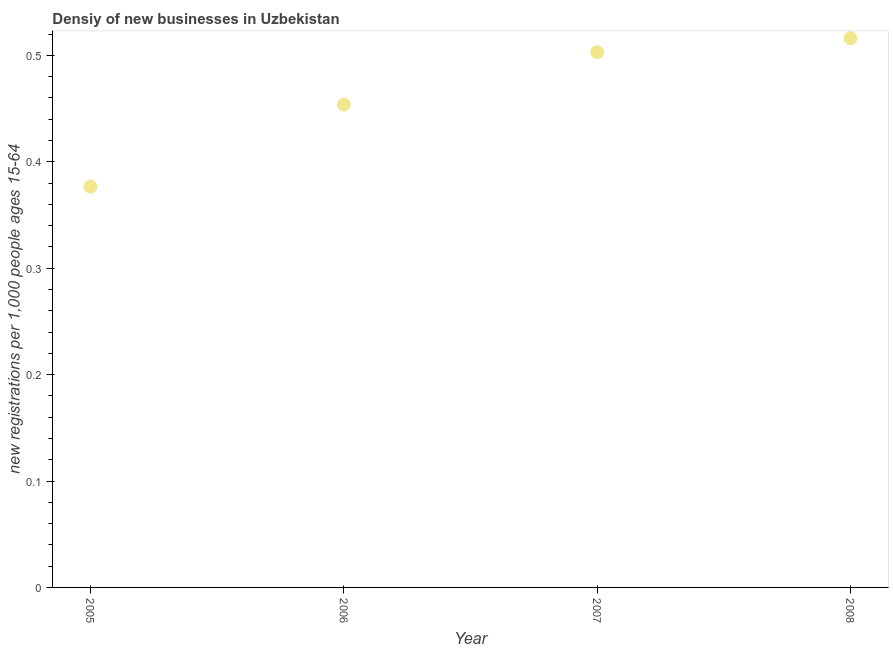What is the density of new business in 2005?
Your response must be concise. 0.38. Across all years, what is the maximum density of new business?
Your answer should be compact. 0.52. Across all years, what is the minimum density of new business?
Provide a short and direct response. 0.38. What is the sum of the density of new business?
Keep it short and to the point. 1.85. What is the difference between the density of new business in 2005 and 2006?
Your answer should be compact. -0.08. What is the average density of new business per year?
Your answer should be compact. 0.46. What is the median density of new business?
Your response must be concise. 0.48. In how many years, is the density of new business greater than 0.12000000000000001 ?
Make the answer very short. 4. Do a majority of the years between 2005 and 2008 (inclusive) have density of new business greater than 0.38000000000000006 ?
Offer a very short reply. Yes. What is the ratio of the density of new business in 2006 to that in 2008?
Keep it short and to the point. 0.88. Is the density of new business in 2006 less than that in 2008?
Provide a succinct answer. Yes. What is the difference between the highest and the second highest density of new business?
Provide a succinct answer. 0.01. What is the difference between the highest and the lowest density of new business?
Offer a terse response. 0.14. In how many years, is the density of new business greater than the average density of new business taken over all years?
Your response must be concise. 2. Does the density of new business monotonically increase over the years?
Give a very brief answer. Yes. How many dotlines are there?
Provide a succinct answer. 1. Are the values on the major ticks of Y-axis written in scientific E-notation?
Provide a succinct answer. No. What is the title of the graph?
Your answer should be very brief. Densiy of new businesses in Uzbekistan. What is the label or title of the Y-axis?
Your answer should be compact. New registrations per 1,0 people ages 15-64. What is the new registrations per 1,000 people ages 15-64 in 2005?
Offer a very short reply. 0.38. What is the new registrations per 1,000 people ages 15-64 in 2006?
Give a very brief answer. 0.45. What is the new registrations per 1,000 people ages 15-64 in 2007?
Offer a very short reply. 0.5. What is the new registrations per 1,000 people ages 15-64 in 2008?
Ensure brevity in your answer.  0.52. What is the difference between the new registrations per 1,000 people ages 15-64 in 2005 and 2006?
Your answer should be compact. -0.08. What is the difference between the new registrations per 1,000 people ages 15-64 in 2005 and 2007?
Keep it short and to the point. -0.13. What is the difference between the new registrations per 1,000 people ages 15-64 in 2005 and 2008?
Make the answer very short. -0.14. What is the difference between the new registrations per 1,000 people ages 15-64 in 2006 and 2007?
Your answer should be compact. -0.05. What is the difference between the new registrations per 1,000 people ages 15-64 in 2006 and 2008?
Offer a terse response. -0.06. What is the difference between the new registrations per 1,000 people ages 15-64 in 2007 and 2008?
Keep it short and to the point. -0.01. What is the ratio of the new registrations per 1,000 people ages 15-64 in 2005 to that in 2006?
Provide a short and direct response. 0.83. What is the ratio of the new registrations per 1,000 people ages 15-64 in 2005 to that in 2007?
Your response must be concise. 0.75. What is the ratio of the new registrations per 1,000 people ages 15-64 in 2005 to that in 2008?
Ensure brevity in your answer.  0.73. What is the ratio of the new registrations per 1,000 people ages 15-64 in 2006 to that in 2007?
Keep it short and to the point. 0.9. What is the ratio of the new registrations per 1,000 people ages 15-64 in 2006 to that in 2008?
Your response must be concise. 0.88. 